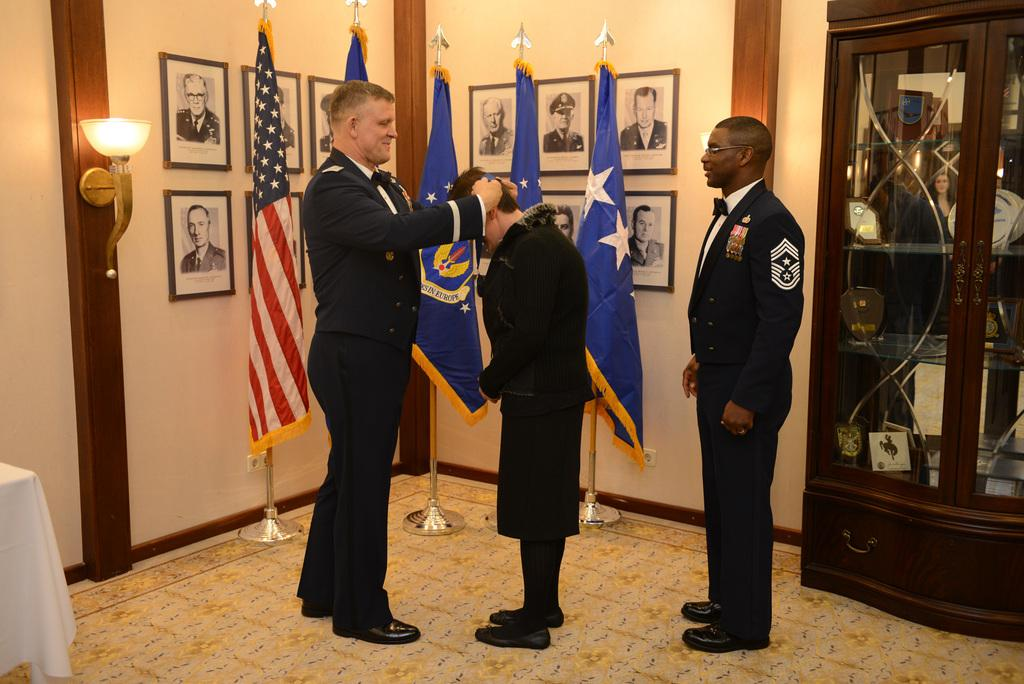What are the people in the image doing? The persons standing in the center of the image are likely interacting or posing for a photo. What can be seen in the background of the image? In the background of the image, there are flags, a wall, photo frames, a light, and a cupboard. Can you describe the lighting in the image? The presence of a light in the background of the image suggests that the scene is well-lit. How many times do the persons in the image bite their nails? There is no indication in the image that the persons are biting their nails, so it cannot be determined from the picture. 